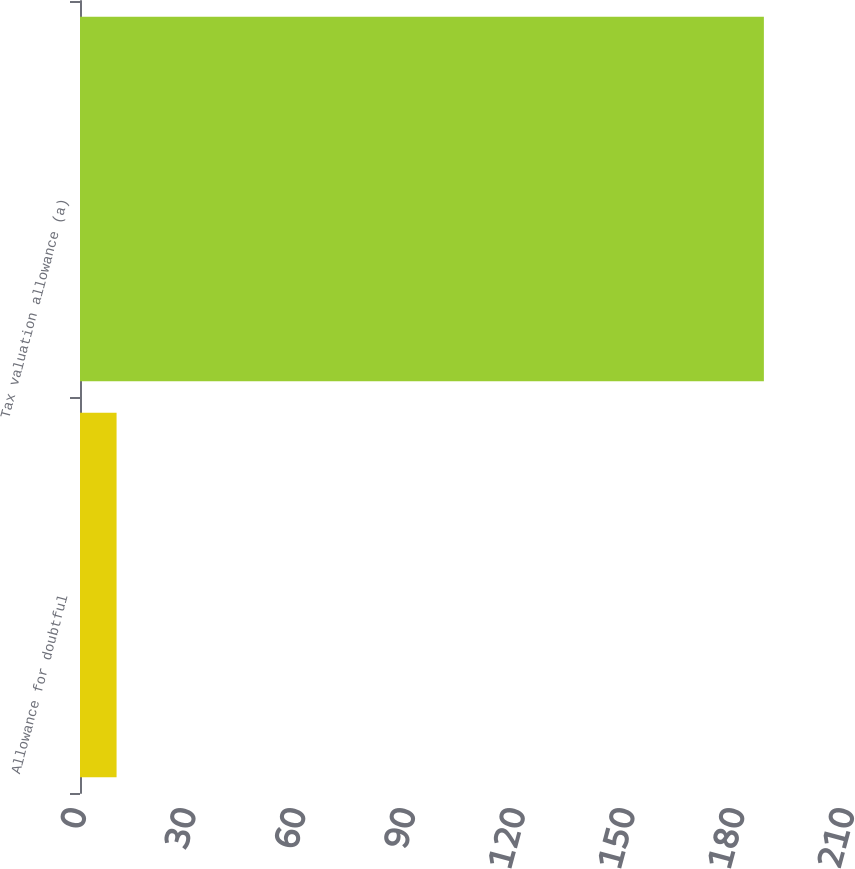Convert chart. <chart><loc_0><loc_0><loc_500><loc_500><bar_chart><fcel>Allowance for doubtful<fcel>Tax valuation allowance (a)<nl><fcel>10<fcel>187<nl></chart> 